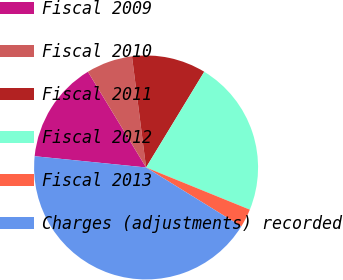Convert chart to OTSL. <chart><loc_0><loc_0><loc_500><loc_500><pie_chart><fcel>Fiscal 2009<fcel>Fiscal 2010<fcel>Fiscal 2011<fcel>Fiscal 2012<fcel>Fiscal 2013<fcel>Charges (adjustments) recorded<nl><fcel>14.71%<fcel>6.68%<fcel>10.7%<fcel>22.46%<fcel>2.67%<fcel>42.78%<nl></chart> 